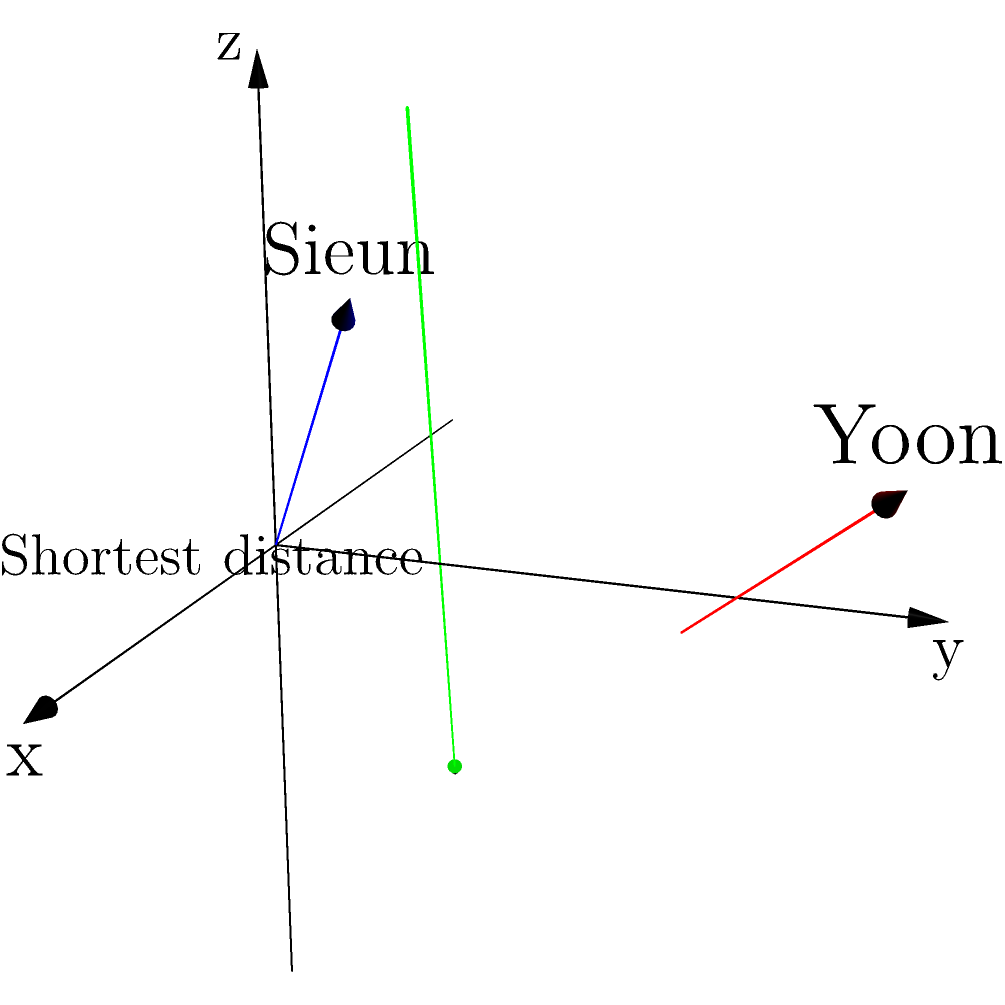In the graph above, two skew lines represent the growth trajectories of STAYC members Sieun (blue line) and Yoon (red line) over time. The x-axis represents their vocal skills, the y-axis represents their dance skills, and the z-axis represents their stage presence. Given that line A (Sieun) passes through points (0,0,0) and (3,1,4), and line B (Yoon) passes through points (1,2,0) and (4,3,3), calculate the shortest distance between these two growth trajectories. To find the shortest distance between two skew lines, we can follow these steps:

1) First, we need to find the direction vectors of both lines:
   $\vec{a} = A_2 - A_1 = (3,1,4) - (0,0,0) = (3,1,4)$
   $\vec{b} = B_2 - B_1 = (4,3,3) - (1,2,0) = (3,1,3)$

2) Next, we calculate the cross product of these direction vectors:
   $\vec{n} = \vec{a} \times \vec{b} = (1\cdot3 - 4\cdot1, 4\cdot3 - 3\cdot3, 3\cdot1 - 1\cdot3) = (-1, 3, 0)$

3) Now, we can find a vector connecting any point on line A to any point on line B:
   $\vec{c} = B_1 - A_1 = (1,2,0) - (0,0,0) = (1,2,0)$

4) The shortest distance is given by the formula:
   $d = \frac{|\vec{c} \cdot \vec{n}|}{|\vec{n}|}$

5) Let's calculate the dot product in the numerator:
   $\vec{c} \cdot \vec{n} = 1(-1) + 2(3) + 0(0) = 5$

6) Now, let's calculate the magnitude of $\vec{n}$:
   $|\vec{n}| = \sqrt{(-1)^2 + 3^2 + 0^2} = \sqrt{10}$

7) Finally, we can calculate the shortest distance:
   $d = \frac{|5|}{\sqrt{10}} = \frac{5}{\sqrt{10}}$

This represents the closest point of approach in their growth trajectories.
Answer: $\frac{5}{\sqrt{10}}$ 